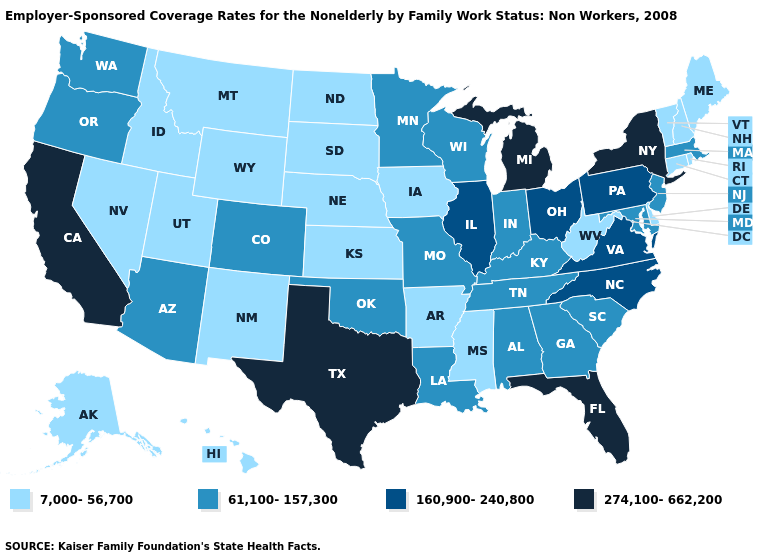What is the value of Virginia?
Give a very brief answer. 160,900-240,800. Does Pennsylvania have the lowest value in the Northeast?
Write a very short answer. No. Name the states that have a value in the range 7,000-56,700?
Concise answer only. Alaska, Arkansas, Connecticut, Delaware, Hawaii, Idaho, Iowa, Kansas, Maine, Mississippi, Montana, Nebraska, Nevada, New Hampshire, New Mexico, North Dakota, Rhode Island, South Dakota, Utah, Vermont, West Virginia, Wyoming. What is the lowest value in the South?
Concise answer only. 7,000-56,700. What is the value of Utah?
Concise answer only. 7,000-56,700. What is the value of South Carolina?
Give a very brief answer. 61,100-157,300. Name the states that have a value in the range 160,900-240,800?
Answer briefly. Illinois, North Carolina, Ohio, Pennsylvania, Virginia. Among the states that border South Carolina , does North Carolina have the highest value?
Be succinct. Yes. Is the legend a continuous bar?
Answer briefly. No. Name the states that have a value in the range 160,900-240,800?
Be succinct. Illinois, North Carolina, Ohio, Pennsylvania, Virginia. Name the states that have a value in the range 7,000-56,700?
Short answer required. Alaska, Arkansas, Connecticut, Delaware, Hawaii, Idaho, Iowa, Kansas, Maine, Mississippi, Montana, Nebraska, Nevada, New Hampshire, New Mexico, North Dakota, Rhode Island, South Dakota, Utah, Vermont, West Virginia, Wyoming. Name the states that have a value in the range 7,000-56,700?
Concise answer only. Alaska, Arkansas, Connecticut, Delaware, Hawaii, Idaho, Iowa, Kansas, Maine, Mississippi, Montana, Nebraska, Nevada, New Hampshire, New Mexico, North Dakota, Rhode Island, South Dakota, Utah, Vermont, West Virginia, Wyoming. What is the lowest value in the Northeast?
Give a very brief answer. 7,000-56,700. Which states have the lowest value in the MidWest?
Answer briefly. Iowa, Kansas, Nebraska, North Dakota, South Dakota. What is the lowest value in the MidWest?
Write a very short answer. 7,000-56,700. 